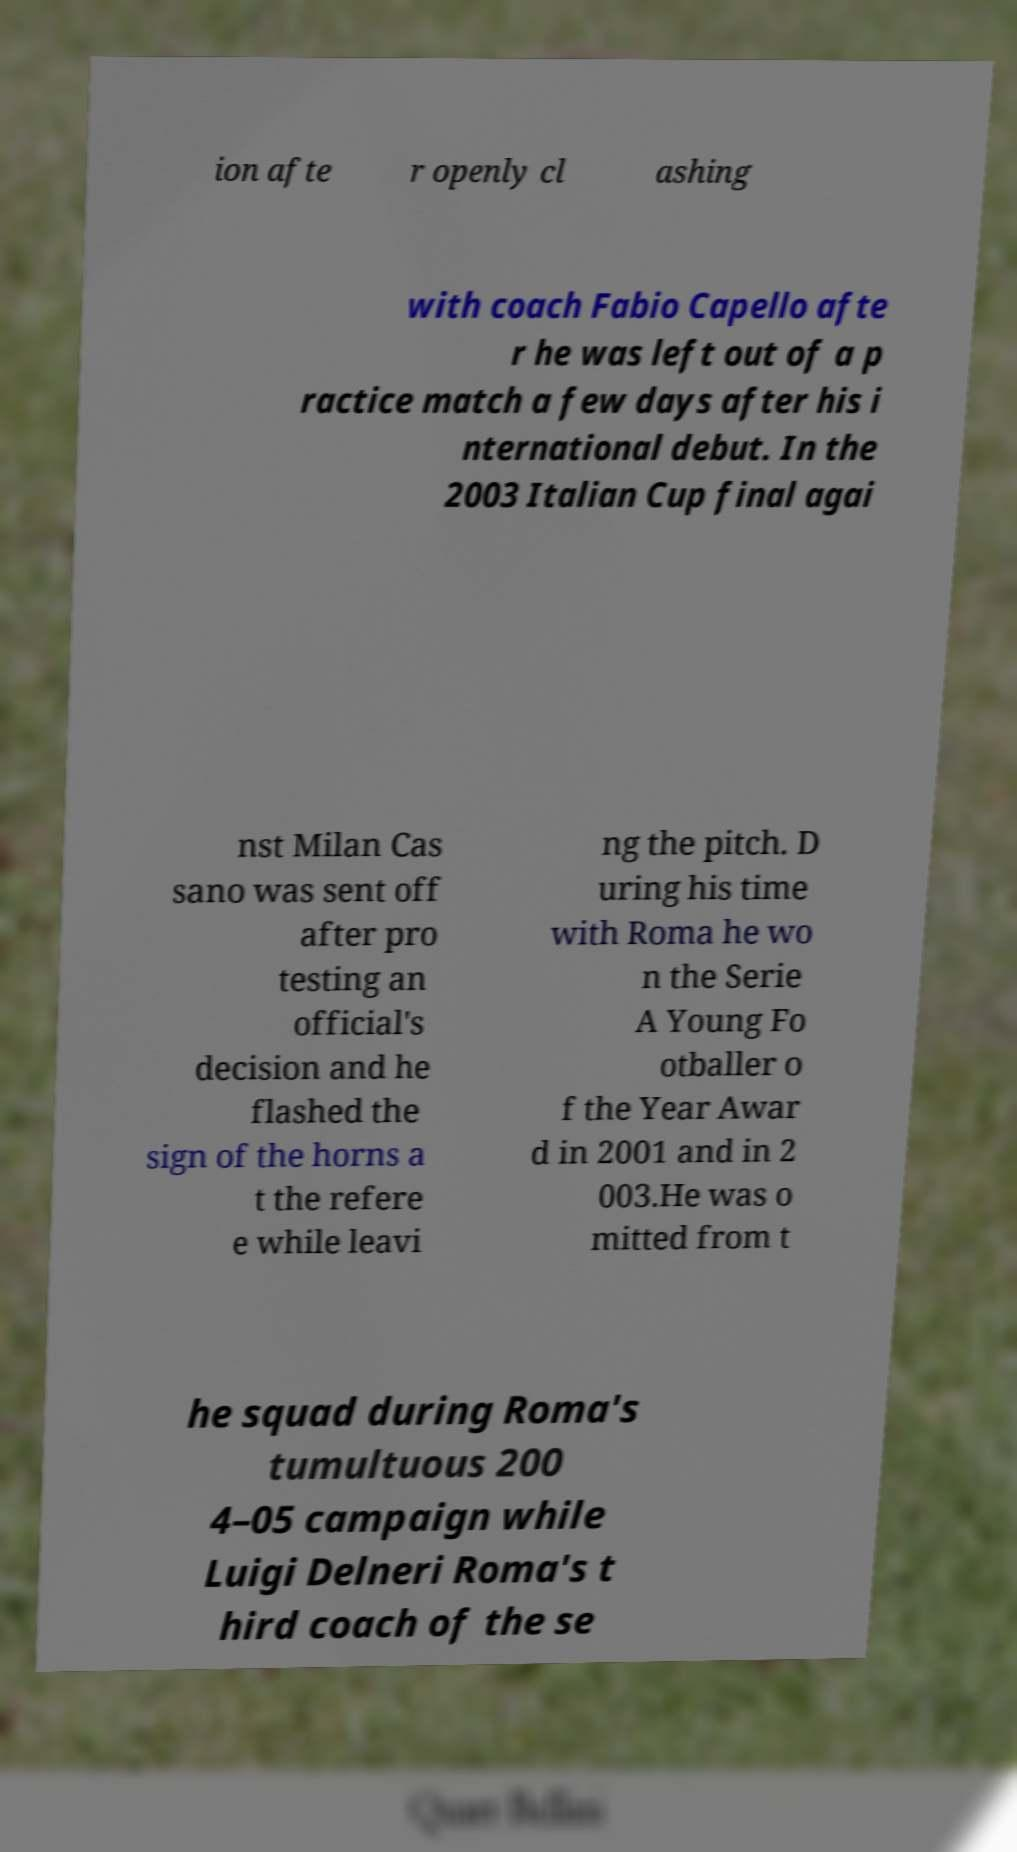For documentation purposes, I need the text within this image transcribed. Could you provide that? ion afte r openly cl ashing with coach Fabio Capello afte r he was left out of a p ractice match a few days after his i nternational debut. In the 2003 Italian Cup final agai nst Milan Cas sano was sent off after pro testing an official's decision and he flashed the sign of the horns a t the refere e while leavi ng the pitch. D uring his time with Roma he wo n the Serie A Young Fo otballer o f the Year Awar d in 2001 and in 2 003.He was o mitted from t he squad during Roma's tumultuous 200 4–05 campaign while Luigi Delneri Roma's t hird coach of the se 